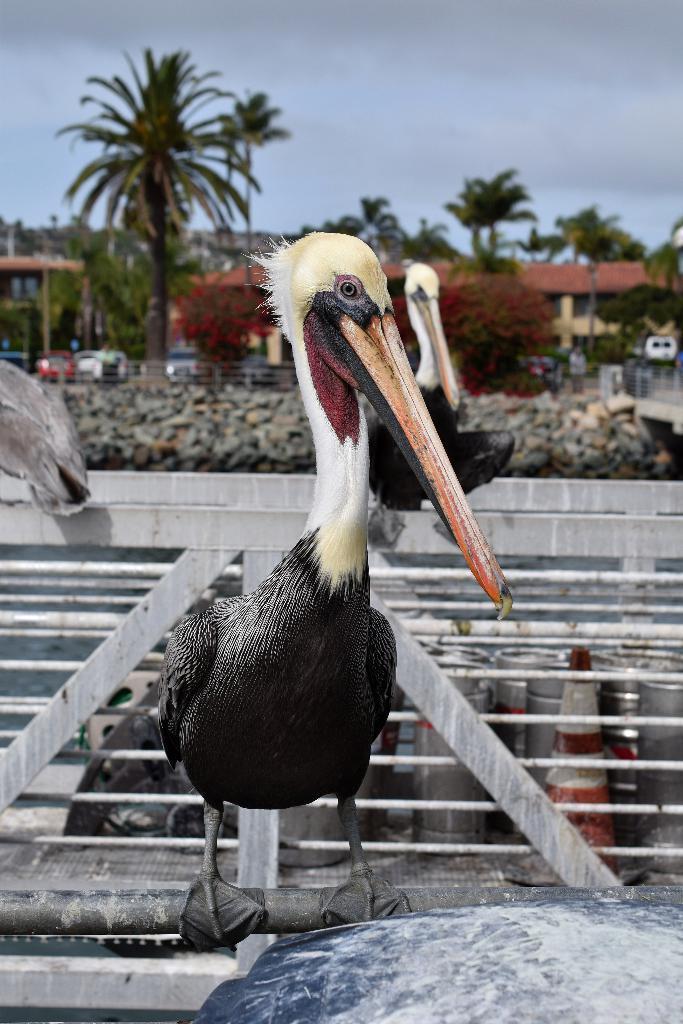Describe this image in one or two sentences. In the foreground of the picture there are birds on an iron frame. In the background we can see buildings, trees, wall, vehicles, people and various other objects. At the top there is sky. 